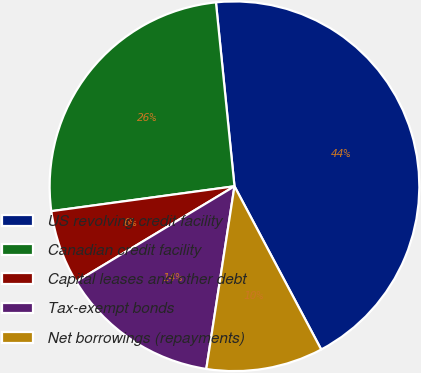Convert chart to OTSL. <chart><loc_0><loc_0><loc_500><loc_500><pie_chart><fcel>US revolving credit facility<fcel>Canadian credit facility<fcel>Capital leases and other debt<fcel>Tax-exempt bonds<fcel>Net borrowings (repayments)<nl><fcel>43.82%<fcel>25.55%<fcel>6.47%<fcel>13.94%<fcel>10.21%<nl></chart> 